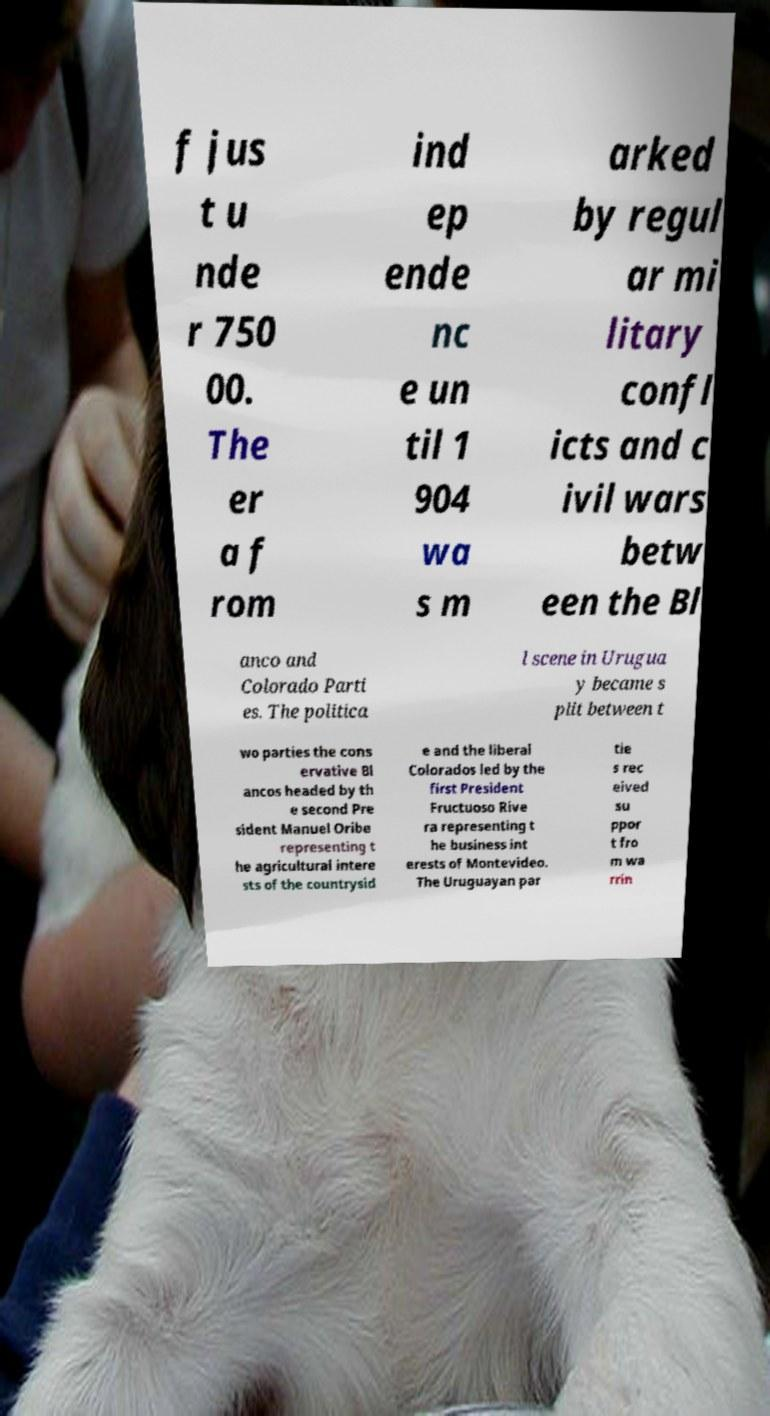Please read and relay the text visible in this image. What does it say? f jus t u nde r 750 00. The er a f rom ind ep ende nc e un til 1 904 wa s m arked by regul ar mi litary confl icts and c ivil wars betw een the Bl anco and Colorado Parti es. The politica l scene in Urugua y became s plit between t wo parties the cons ervative Bl ancos headed by th e second Pre sident Manuel Oribe representing t he agricultural intere sts of the countrysid e and the liberal Colorados led by the first President Fructuoso Rive ra representing t he business int erests of Montevideo. The Uruguayan par tie s rec eived su ppor t fro m wa rrin 